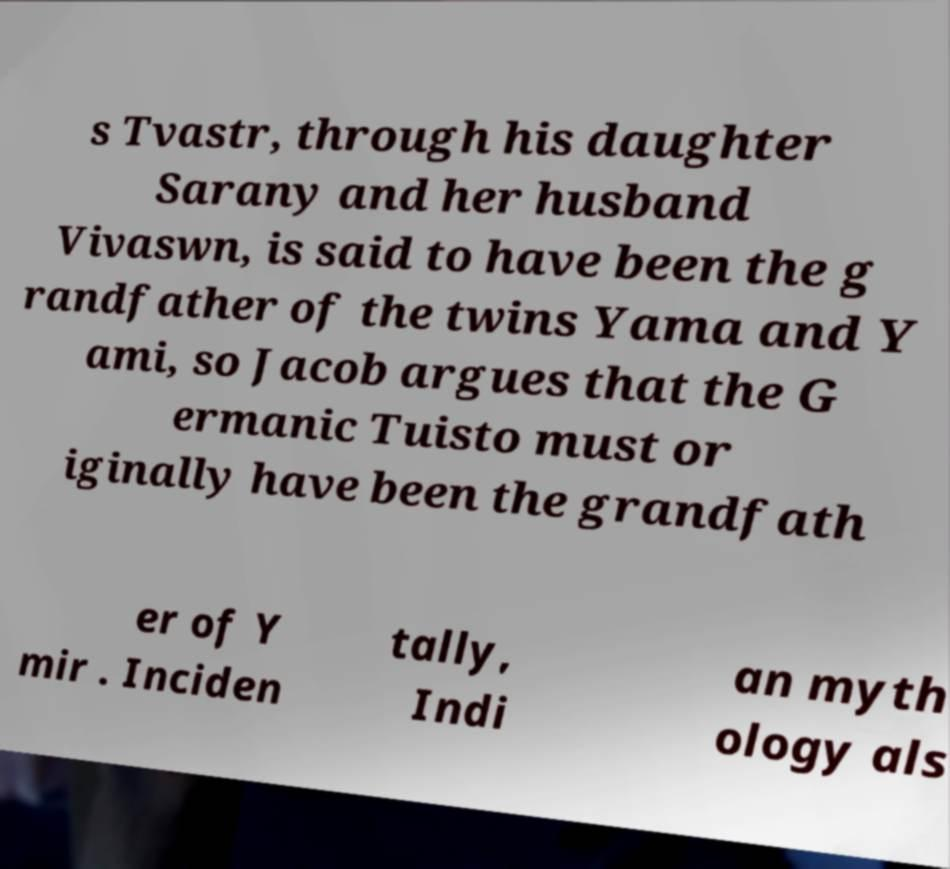Could you assist in decoding the text presented in this image and type it out clearly? s Tvastr, through his daughter Sarany and her husband Vivaswn, is said to have been the g randfather of the twins Yama and Y ami, so Jacob argues that the G ermanic Tuisto must or iginally have been the grandfath er of Y mir . Inciden tally, Indi an myth ology als 